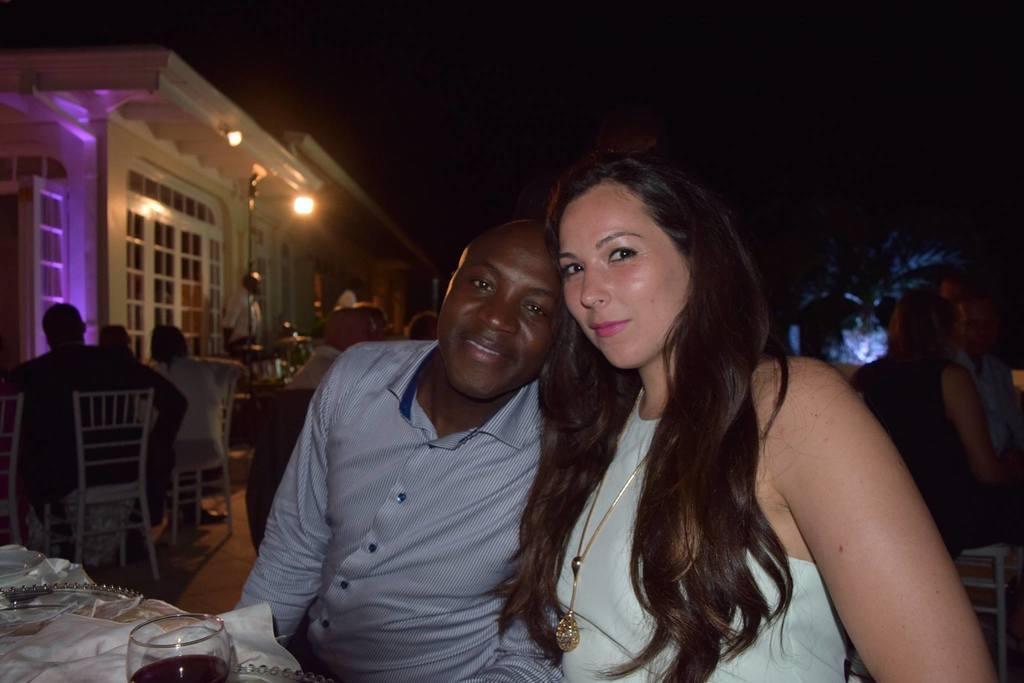Could you give a brief overview of what you see in this image? In this picture we can see a man and woman sitting on chair and they are smiling and in front of them on table we have glass with drink in it, cloth and in the background we can see wall, light, some more persons and it is dark. 